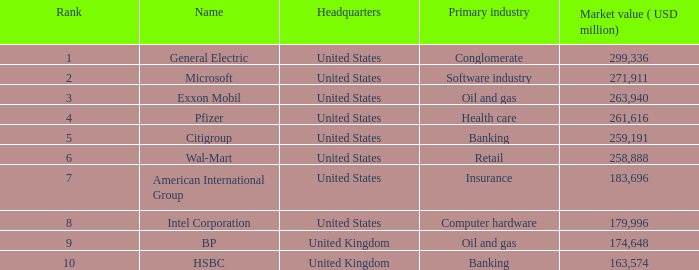How many ranks have an industry of health care? 1.0. 